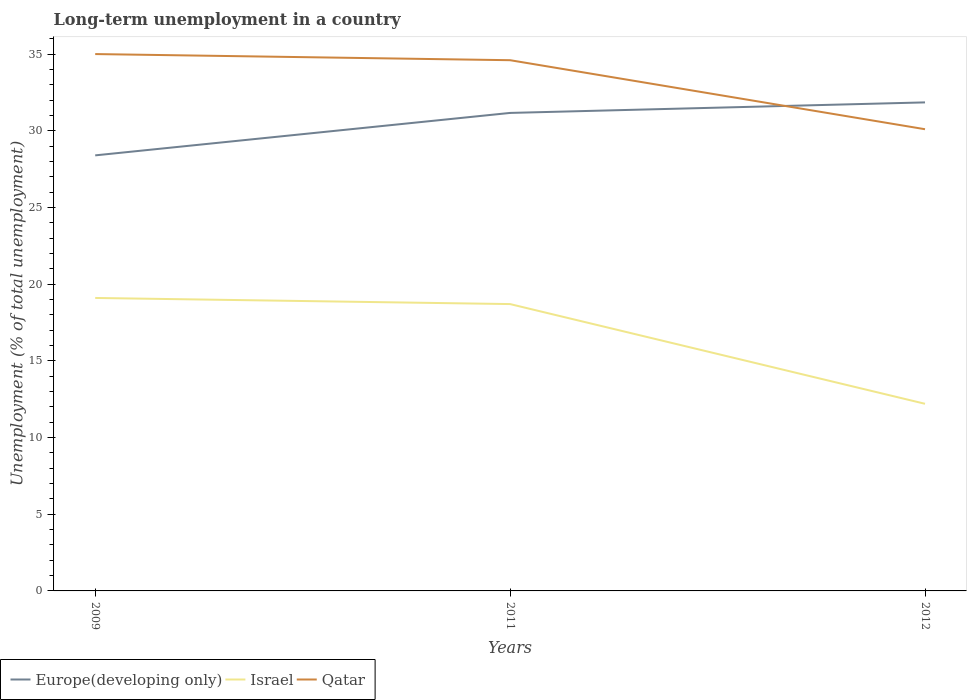Is the number of lines equal to the number of legend labels?
Ensure brevity in your answer.  Yes. Across all years, what is the maximum percentage of long-term unemployed population in Qatar?
Ensure brevity in your answer.  30.1. What is the total percentage of long-term unemployed population in Qatar in the graph?
Provide a succinct answer. 0.4. What is the difference between the highest and the second highest percentage of long-term unemployed population in Qatar?
Offer a terse response. 4.9. How many lines are there?
Give a very brief answer. 3. How many years are there in the graph?
Provide a succinct answer. 3. What is the difference between two consecutive major ticks on the Y-axis?
Provide a short and direct response. 5. What is the title of the graph?
Give a very brief answer. Long-term unemployment in a country. What is the label or title of the X-axis?
Your answer should be compact. Years. What is the label or title of the Y-axis?
Your response must be concise. Unemployment (% of total unemployment). What is the Unemployment (% of total unemployment) in Europe(developing only) in 2009?
Provide a succinct answer. 28.4. What is the Unemployment (% of total unemployment) of Israel in 2009?
Offer a very short reply. 19.1. What is the Unemployment (% of total unemployment) of Europe(developing only) in 2011?
Your answer should be compact. 31.16. What is the Unemployment (% of total unemployment) in Israel in 2011?
Your response must be concise. 18.7. What is the Unemployment (% of total unemployment) in Qatar in 2011?
Your answer should be very brief. 34.6. What is the Unemployment (% of total unemployment) in Europe(developing only) in 2012?
Ensure brevity in your answer.  31.85. What is the Unemployment (% of total unemployment) in Israel in 2012?
Offer a very short reply. 12.2. What is the Unemployment (% of total unemployment) of Qatar in 2012?
Make the answer very short. 30.1. Across all years, what is the maximum Unemployment (% of total unemployment) of Europe(developing only)?
Make the answer very short. 31.85. Across all years, what is the maximum Unemployment (% of total unemployment) of Israel?
Offer a very short reply. 19.1. Across all years, what is the minimum Unemployment (% of total unemployment) in Europe(developing only)?
Your answer should be very brief. 28.4. Across all years, what is the minimum Unemployment (% of total unemployment) of Israel?
Give a very brief answer. 12.2. Across all years, what is the minimum Unemployment (% of total unemployment) in Qatar?
Give a very brief answer. 30.1. What is the total Unemployment (% of total unemployment) of Europe(developing only) in the graph?
Provide a succinct answer. 91.41. What is the total Unemployment (% of total unemployment) of Qatar in the graph?
Your answer should be very brief. 99.7. What is the difference between the Unemployment (% of total unemployment) in Europe(developing only) in 2009 and that in 2011?
Your answer should be very brief. -2.77. What is the difference between the Unemployment (% of total unemployment) in Israel in 2009 and that in 2011?
Offer a very short reply. 0.4. What is the difference between the Unemployment (% of total unemployment) in Europe(developing only) in 2009 and that in 2012?
Offer a very short reply. -3.45. What is the difference between the Unemployment (% of total unemployment) in Qatar in 2009 and that in 2012?
Ensure brevity in your answer.  4.9. What is the difference between the Unemployment (% of total unemployment) in Europe(developing only) in 2011 and that in 2012?
Offer a very short reply. -0.69. What is the difference between the Unemployment (% of total unemployment) of Europe(developing only) in 2009 and the Unemployment (% of total unemployment) of Israel in 2011?
Provide a short and direct response. 9.7. What is the difference between the Unemployment (% of total unemployment) of Europe(developing only) in 2009 and the Unemployment (% of total unemployment) of Qatar in 2011?
Your answer should be compact. -6.2. What is the difference between the Unemployment (% of total unemployment) in Israel in 2009 and the Unemployment (% of total unemployment) in Qatar in 2011?
Offer a terse response. -15.5. What is the difference between the Unemployment (% of total unemployment) of Europe(developing only) in 2009 and the Unemployment (% of total unemployment) of Israel in 2012?
Give a very brief answer. 16.2. What is the difference between the Unemployment (% of total unemployment) of Europe(developing only) in 2009 and the Unemployment (% of total unemployment) of Qatar in 2012?
Offer a terse response. -1.7. What is the difference between the Unemployment (% of total unemployment) of Europe(developing only) in 2011 and the Unemployment (% of total unemployment) of Israel in 2012?
Keep it short and to the point. 18.96. What is the difference between the Unemployment (% of total unemployment) of Europe(developing only) in 2011 and the Unemployment (% of total unemployment) of Qatar in 2012?
Keep it short and to the point. 1.06. What is the difference between the Unemployment (% of total unemployment) in Israel in 2011 and the Unemployment (% of total unemployment) in Qatar in 2012?
Provide a short and direct response. -11.4. What is the average Unemployment (% of total unemployment) in Europe(developing only) per year?
Offer a terse response. 30.47. What is the average Unemployment (% of total unemployment) of Israel per year?
Ensure brevity in your answer.  16.67. What is the average Unemployment (% of total unemployment) of Qatar per year?
Your answer should be compact. 33.23. In the year 2009, what is the difference between the Unemployment (% of total unemployment) of Europe(developing only) and Unemployment (% of total unemployment) of Israel?
Make the answer very short. 9.3. In the year 2009, what is the difference between the Unemployment (% of total unemployment) of Europe(developing only) and Unemployment (% of total unemployment) of Qatar?
Offer a very short reply. -6.6. In the year 2009, what is the difference between the Unemployment (% of total unemployment) in Israel and Unemployment (% of total unemployment) in Qatar?
Keep it short and to the point. -15.9. In the year 2011, what is the difference between the Unemployment (% of total unemployment) in Europe(developing only) and Unemployment (% of total unemployment) in Israel?
Your answer should be very brief. 12.46. In the year 2011, what is the difference between the Unemployment (% of total unemployment) in Europe(developing only) and Unemployment (% of total unemployment) in Qatar?
Ensure brevity in your answer.  -3.44. In the year 2011, what is the difference between the Unemployment (% of total unemployment) in Israel and Unemployment (% of total unemployment) in Qatar?
Keep it short and to the point. -15.9. In the year 2012, what is the difference between the Unemployment (% of total unemployment) of Europe(developing only) and Unemployment (% of total unemployment) of Israel?
Your response must be concise. 19.65. In the year 2012, what is the difference between the Unemployment (% of total unemployment) in Europe(developing only) and Unemployment (% of total unemployment) in Qatar?
Keep it short and to the point. 1.75. In the year 2012, what is the difference between the Unemployment (% of total unemployment) of Israel and Unemployment (% of total unemployment) of Qatar?
Give a very brief answer. -17.9. What is the ratio of the Unemployment (% of total unemployment) of Europe(developing only) in 2009 to that in 2011?
Give a very brief answer. 0.91. What is the ratio of the Unemployment (% of total unemployment) in Israel in 2009 to that in 2011?
Ensure brevity in your answer.  1.02. What is the ratio of the Unemployment (% of total unemployment) of Qatar in 2009 to that in 2011?
Your answer should be very brief. 1.01. What is the ratio of the Unemployment (% of total unemployment) in Europe(developing only) in 2009 to that in 2012?
Offer a terse response. 0.89. What is the ratio of the Unemployment (% of total unemployment) of Israel in 2009 to that in 2012?
Provide a short and direct response. 1.57. What is the ratio of the Unemployment (% of total unemployment) of Qatar in 2009 to that in 2012?
Ensure brevity in your answer.  1.16. What is the ratio of the Unemployment (% of total unemployment) of Europe(developing only) in 2011 to that in 2012?
Give a very brief answer. 0.98. What is the ratio of the Unemployment (% of total unemployment) in Israel in 2011 to that in 2012?
Your answer should be very brief. 1.53. What is the ratio of the Unemployment (% of total unemployment) in Qatar in 2011 to that in 2012?
Make the answer very short. 1.15. What is the difference between the highest and the second highest Unemployment (% of total unemployment) in Europe(developing only)?
Your answer should be very brief. 0.69. What is the difference between the highest and the second highest Unemployment (% of total unemployment) in Israel?
Your answer should be compact. 0.4. What is the difference between the highest and the lowest Unemployment (% of total unemployment) of Europe(developing only)?
Offer a very short reply. 3.45. What is the difference between the highest and the lowest Unemployment (% of total unemployment) of Israel?
Your answer should be very brief. 6.9. 